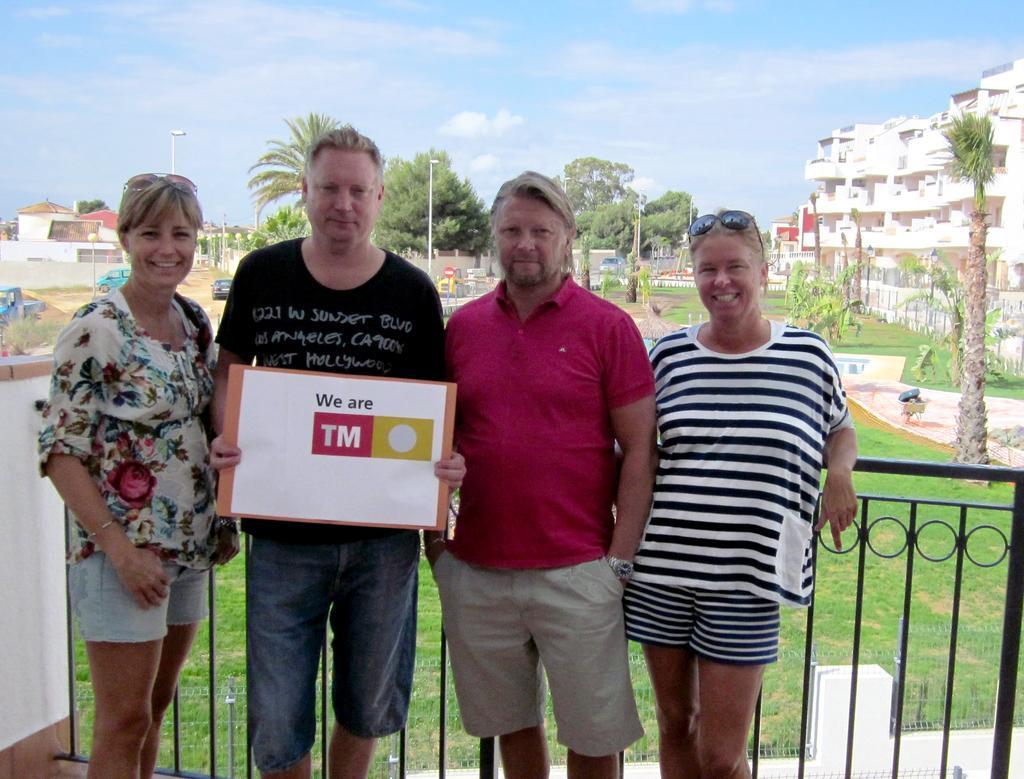Can you describe this image briefly? In the image there are four persons standing. There is a man holding a poster in the hand. Behind them there is railing. Behind the railing on the ground there is grass and also there are vehicles and poles with lamps. In the background there are trees. At the top of the image there is sky with clouds. 